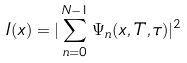<formula> <loc_0><loc_0><loc_500><loc_500>I ( x ) = | \sum _ { n = 0 } ^ { N - 1 } \Psi _ { n } ( x , T , \tau ) | ^ { 2 }</formula> 